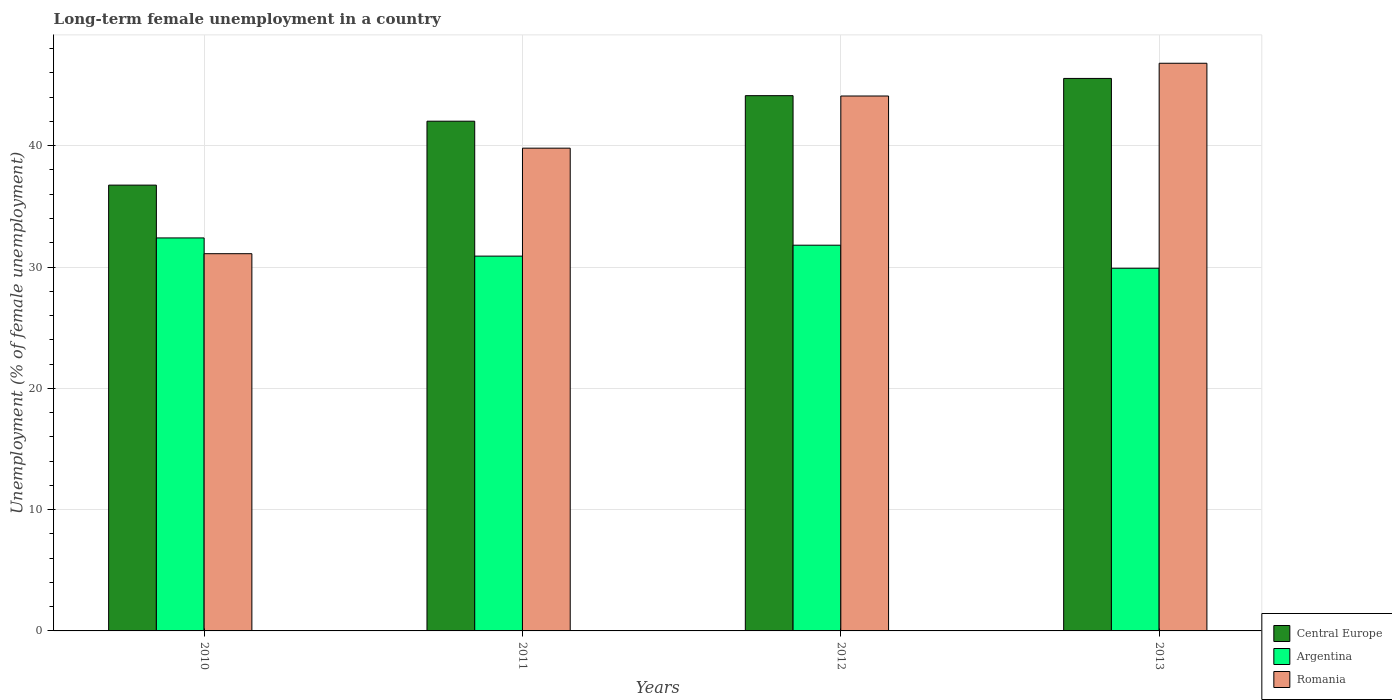How many different coloured bars are there?
Make the answer very short. 3. Are the number of bars per tick equal to the number of legend labels?
Make the answer very short. Yes. Are the number of bars on each tick of the X-axis equal?
Provide a succinct answer. Yes. How many bars are there on the 1st tick from the left?
Offer a very short reply. 3. How many bars are there on the 2nd tick from the right?
Keep it short and to the point. 3. In how many cases, is the number of bars for a given year not equal to the number of legend labels?
Offer a terse response. 0. What is the percentage of long-term unemployed female population in Central Europe in 2011?
Keep it short and to the point. 42.02. Across all years, what is the maximum percentage of long-term unemployed female population in Argentina?
Keep it short and to the point. 32.4. Across all years, what is the minimum percentage of long-term unemployed female population in Argentina?
Offer a very short reply. 29.9. In which year was the percentage of long-term unemployed female population in Argentina minimum?
Ensure brevity in your answer.  2013. What is the total percentage of long-term unemployed female population in Argentina in the graph?
Provide a short and direct response. 125. What is the difference between the percentage of long-term unemployed female population in Romania in 2011 and that in 2012?
Offer a terse response. -4.3. What is the difference between the percentage of long-term unemployed female population in Argentina in 2011 and the percentage of long-term unemployed female population in Central Europe in 2013?
Make the answer very short. -14.65. What is the average percentage of long-term unemployed female population in Romania per year?
Offer a terse response. 40.45. In the year 2013, what is the difference between the percentage of long-term unemployed female population in Central Europe and percentage of long-term unemployed female population in Argentina?
Your response must be concise. 15.65. In how many years, is the percentage of long-term unemployed female population in Argentina greater than 28 %?
Keep it short and to the point. 4. What is the ratio of the percentage of long-term unemployed female population in Romania in 2010 to that in 2013?
Make the answer very short. 0.66. Is the difference between the percentage of long-term unemployed female population in Central Europe in 2010 and 2013 greater than the difference between the percentage of long-term unemployed female population in Argentina in 2010 and 2013?
Make the answer very short. No. What is the difference between the highest and the second highest percentage of long-term unemployed female population in Central Europe?
Offer a terse response. 1.42. What is the difference between the highest and the lowest percentage of long-term unemployed female population in Argentina?
Ensure brevity in your answer.  2.5. Is the sum of the percentage of long-term unemployed female population in Argentina in 2010 and 2012 greater than the maximum percentage of long-term unemployed female population in Central Europe across all years?
Provide a short and direct response. Yes. What does the 3rd bar from the right in 2011 represents?
Give a very brief answer. Central Europe. Are all the bars in the graph horizontal?
Offer a terse response. No. Are the values on the major ticks of Y-axis written in scientific E-notation?
Offer a very short reply. No. Does the graph contain grids?
Your answer should be very brief. Yes. How many legend labels are there?
Make the answer very short. 3. How are the legend labels stacked?
Make the answer very short. Vertical. What is the title of the graph?
Your response must be concise. Long-term female unemployment in a country. What is the label or title of the X-axis?
Ensure brevity in your answer.  Years. What is the label or title of the Y-axis?
Make the answer very short. Unemployment (% of female unemployment). What is the Unemployment (% of female unemployment) of Central Europe in 2010?
Ensure brevity in your answer.  36.75. What is the Unemployment (% of female unemployment) in Argentina in 2010?
Your answer should be very brief. 32.4. What is the Unemployment (% of female unemployment) in Romania in 2010?
Give a very brief answer. 31.1. What is the Unemployment (% of female unemployment) in Central Europe in 2011?
Provide a succinct answer. 42.02. What is the Unemployment (% of female unemployment) in Argentina in 2011?
Your answer should be compact. 30.9. What is the Unemployment (% of female unemployment) of Romania in 2011?
Provide a short and direct response. 39.8. What is the Unemployment (% of female unemployment) in Central Europe in 2012?
Offer a very short reply. 44.13. What is the Unemployment (% of female unemployment) in Argentina in 2012?
Your answer should be very brief. 31.8. What is the Unemployment (% of female unemployment) in Romania in 2012?
Give a very brief answer. 44.1. What is the Unemployment (% of female unemployment) of Central Europe in 2013?
Ensure brevity in your answer.  45.55. What is the Unemployment (% of female unemployment) in Argentina in 2013?
Provide a short and direct response. 29.9. What is the Unemployment (% of female unemployment) in Romania in 2013?
Make the answer very short. 46.8. Across all years, what is the maximum Unemployment (% of female unemployment) of Central Europe?
Offer a very short reply. 45.55. Across all years, what is the maximum Unemployment (% of female unemployment) in Argentina?
Make the answer very short. 32.4. Across all years, what is the maximum Unemployment (% of female unemployment) of Romania?
Offer a terse response. 46.8. Across all years, what is the minimum Unemployment (% of female unemployment) in Central Europe?
Your response must be concise. 36.75. Across all years, what is the minimum Unemployment (% of female unemployment) of Argentina?
Ensure brevity in your answer.  29.9. Across all years, what is the minimum Unemployment (% of female unemployment) of Romania?
Provide a succinct answer. 31.1. What is the total Unemployment (% of female unemployment) of Central Europe in the graph?
Offer a very short reply. 168.46. What is the total Unemployment (% of female unemployment) of Argentina in the graph?
Ensure brevity in your answer.  125. What is the total Unemployment (% of female unemployment) in Romania in the graph?
Provide a succinct answer. 161.8. What is the difference between the Unemployment (% of female unemployment) in Central Europe in 2010 and that in 2011?
Make the answer very short. -5.27. What is the difference between the Unemployment (% of female unemployment) in Romania in 2010 and that in 2011?
Your response must be concise. -8.7. What is the difference between the Unemployment (% of female unemployment) in Central Europe in 2010 and that in 2012?
Make the answer very short. -7.37. What is the difference between the Unemployment (% of female unemployment) of Argentina in 2010 and that in 2012?
Ensure brevity in your answer.  0.6. What is the difference between the Unemployment (% of female unemployment) in Romania in 2010 and that in 2012?
Keep it short and to the point. -13. What is the difference between the Unemployment (% of female unemployment) in Central Europe in 2010 and that in 2013?
Your response must be concise. -8.8. What is the difference between the Unemployment (% of female unemployment) in Romania in 2010 and that in 2013?
Make the answer very short. -15.7. What is the difference between the Unemployment (% of female unemployment) in Central Europe in 2011 and that in 2012?
Ensure brevity in your answer.  -2.1. What is the difference between the Unemployment (% of female unemployment) of Argentina in 2011 and that in 2012?
Provide a succinct answer. -0.9. What is the difference between the Unemployment (% of female unemployment) of Central Europe in 2011 and that in 2013?
Provide a short and direct response. -3.53. What is the difference between the Unemployment (% of female unemployment) of Argentina in 2011 and that in 2013?
Ensure brevity in your answer.  1. What is the difference between the Unemployment (% of female unemployment) in Central Europe in 2012 and that in 2013?
Offer a terse response. -1.42. What is the difference between the Unemployment (% of female unemployment) of Romania in 2012 and that in 2013?
Give a very brief answer. -2.7. What is the difference between the Unemployment (% of female unemployment) in Central Europe in 2010 and the Unemployment (% of female unemployment) in Argentina in 2011?
Provide a short and direct response. 5.85. What is the difference between the Unemployment (% of female unemployment) of Central Europe in 2010 and the Unemployment (% of female unemployment) of Romania in 2011?
Provide a short and direct response. -3.05. What is the difference between the Unemployment (% of female unemployment) of Argentina in 2010 and the Unemployment (% of female unemployment) of Romania in 2011?
Your answer should be compact. -7.4. What is the difference between the Unemployment (% of female unemployment) in Central Europe in 2010 and the Unemployment (% of female unemployment) in Argentina in 2012?
Provide a short and direct response. 4.95. What is the difference between the Unemployment (% of female unemployment) in Central Europe in 2010 and the Unemployment (% of female unemployment) in Romania in 2012?
Provide a short and direct response. -7.35. What is the difference between the Unemployment (% of female unemployment) in Argentina in 2010 and the Unemployment (% of female unemployment) in Romania in 2012?
Give a very brief answer. -11.7. What is the difference between the Unemployment (% of female unemployment) of Central Europe in 2010 and the Unemployment (% of female unemployment) of Argentina in 2013?
Offer a very short reply. 6.85. What is the difference between the Unemployment (% of female unemployment) of Central Europe in 2010 and the Unemployment (% of female unemployment) of Romania in 2013?
Give a very brief answer. -10.05. What is the difference between the Unemployment (% of female unemployment) of Argentina in 2010 and the Unemployment (% of female unemployment) of Romania in 2013?
Keep it short and to the point. -14.4. What is the difference between the Unemployment (% of female unemployment) of Central Europe in 2011 and the Unemployment (% of female unemployment) of Argentina in 2012?
Give a very brief answer. 10.22. What is the difference between the Unemployment (% of female unemployment) in Central Europe in 2011 and the Unemployment (% of female unemployment) in Romania in 2012?
Provide a short and direct response. -2.08. What is the difference between the Unemployment (% of female unemployment) in Argentina in 2011 and the Unemployment (% of female unemployment) in Romania in 2012?
Offer a terse response. -13.2. What is the difference between the Unemployment (% of female unemployment) in Central Europe in 2011 and the Unemployment (% of female unemployment) in Argentina in 2013?
Keep it short and to the point. 12.12. What is the difference between the Unemployment (% of female unemployment) in Central Europe in 2011 and the Unemployment (% of female unemployment) in Romania in 2013?
Ensure brevity in your answer.  -4.78. What is the difference between the Unemployment (% of female unemployment) of Argentina in 2011 and the Unemployment (% of female unemployment) of Romania in 2013?
Offer a very short reply. -15.9. What is the difference between the Unemployment (% of female unemployment) in Central Europe in 2012 and the Unemployment (% of female unemployment) in Argentina in 2013?
Offer a very short reply. 14.23. What is the difference between the Unemployment (% of female unemployment) in Central Europe in 2012 and the Unemployment (% of female unemployment) in Romania in 2013?
Provide a succinct answer. -2.67. What is the difference between the Unemployment (% of female unemployment) of Argentina in 2012 and the Unemployment (% of female unemployment) of Romania in 2013?
Your answer should be compact. -15. What is the average Unemployment (% of female unemployment) of Central Europe per year?
Offer a terse response. 42.11. What is the average Unemployment (% of female unemployment) in Argentina per year?
Provide a short and direct response. 31.25. What is the average Unemployment (% of female unemployment) of Romania per year?
Provide a short and direct response. 40.45. In the year 2010, what is the difference between the Unemployment (% of female unemployment) in Central Europe and Unemployment (% of female unemployment) in Argentina?
Provide a succinct answer. 4.35. In the year 2010, what is the difference between the Unemployment (% of female unemployment) in Central Europe and Unemployment (% of female unemployment) in Romania?
Ensure brevity in your answer.  5.65. In the year 2010, what is the difference between the Unemployment (% of female unemployment) in Argentina and Unemployment (% of female unemployment) in Romania?
Your response must be concise. 1.3. In the year 2011, what is the difference between the Unemployment (% of female unemployment) in Central Europe and Unemployment (% of female unemployment) in Argentina?
Your response must be concise. 11.12. In the year 2011, what is the difference between the Unemployment (% of female unemployment) of Central Europe and Unemployment (% of female unemployment) of Romania?
Provide a short and direct response. 2.22. In the year 2011, what is the difference between the Unemployment (% of female unemployment) of Argentina and Unemployment (% of female unemployment) of Romania?
Offer a terse response. -8.9. In the year 2012, what is the difference between the Unemployment (% of female unemployment) of Central Europe and Unemployment (% of female unemployment) of Argentina?
Offer a terse response. 12.33. In the year 2012, what is the difference between the Unemployment (% of female unemployment) in Central Europe and Unemployment (% of female unemployment) in Romania?
Offer a terse response. 0.03. In the year 2012, what is the difference between the Unemployment (% of female unemployment) of Argentina and Unemployment (% of female unemployment) of Romania?
Your answer should be compact. -12.3. In the year 2013, what is the difference between the Unemployment (% of female unemployment) in Central Europe and Unemployment (% of female unemployment) in Argentina?
Offer a terse response. 15.65. In the year 2013, what is the difference between the Unemployment (% of female unemployment) of Central Europe and Unemployment (% of female unemployment) of Romania?
Provide a succinct answer. -1.25. In the year 2013, what is the difference between the Unemployment (% of female unemployment) of Argentina and Unemployment (% of female unemployment) of Romania?
Offer a terse response. -16.9. What is the ratio of the Unemployment (% of female unemployment) of Central Europe in 2010 to that in 2011?
Provide a short and direct response. 0.87. What is the ratio of the Unemployment (% of female unemployment) of Argentina in 2010 to that in 2011?
Offer a terse response. 1.05. What is the ratio of the Unemployment (% of female unemployment) in Romania in 2010 to that in 2011?
Provide a succinct answer. 0.78. What is the ratio of the Unemployment (% of female unemployment) of Central Europe in 2010 to that in 2012?
Your answer should be very brief. 0.83. What is the ratio of the Unemployment (% of female unemployment) of Argentina in 2010 to that in 2012?
Offer a terse response. 1.02. What is the ratio of the Unemployment (% of female unemployment) of Romania in 2010 to that in 2012?
Provide a succinct answer. 0.71. What is the ratio of the Unemployment (% of female unemployment) in Central Europe in 2010 to that in 2013?
Your response must be concise. 0.81. What is the ratio of the Unemployment (% of female unemployment) of Argentina in 2010 to that in 2013?
Your response must be concise. 1.08. What is the ratio of the Unemployment (% of female unemployment) in Romania in 2010 to that in 2013?
Make the answer very short. 0.66. What is the ratio of the Unemployment (% of female unemployment) of Central Europe in 2011 to that in 2012?
Make the answer very short. 0.95. What is the ratio of the Unemployment (% of female unemployment) in Argentina in 2011 to that in 2012?
Provide a succinct answer. 0.97. What is the ratio of the Unemployment (% of female unemployment) in Romania in 2011 to that in 2012?
Provide a succinct answer. 0.9. What is the ratio of the Unemployment (% of female unemployment) of Central Europe in 2011 to that in 2013?
Your answer should be very brief. 0.92. What is the ratio of the Unemployment (% of female unemployment) of Argentina in 2011 to that in 2013?
Make the answer very short. 1.03. What is the ratio of the Unemployment (% of female unemployment) of Romania in 2011 to that in 2013?
Give a very brief answer. 0.85. What is the ratio of the Unemployment (% of female unemployment) of Central Europe in 2012 to that in 2013?
Make the answer very short. 0.97. What is the ratio of the Unemployment (% of female unemployment) in Argentina in 2012 to that in 2013?
Your answer should be compact. 1.06. What is the ratio of the Unemployment (% of female unemployment) of Romania in 2012 to that in 2013?
Your answer should be compact. 0.94. What is the difference between the highest and the second highest Unemployment (% of female unemployment) in Central Europe?
Your answer should be very brief. 1.42. What is the difference between the highest and the lowest Unemployment (% of female unemployment) in Central Europe?
Offer a terse response. 8.8. 